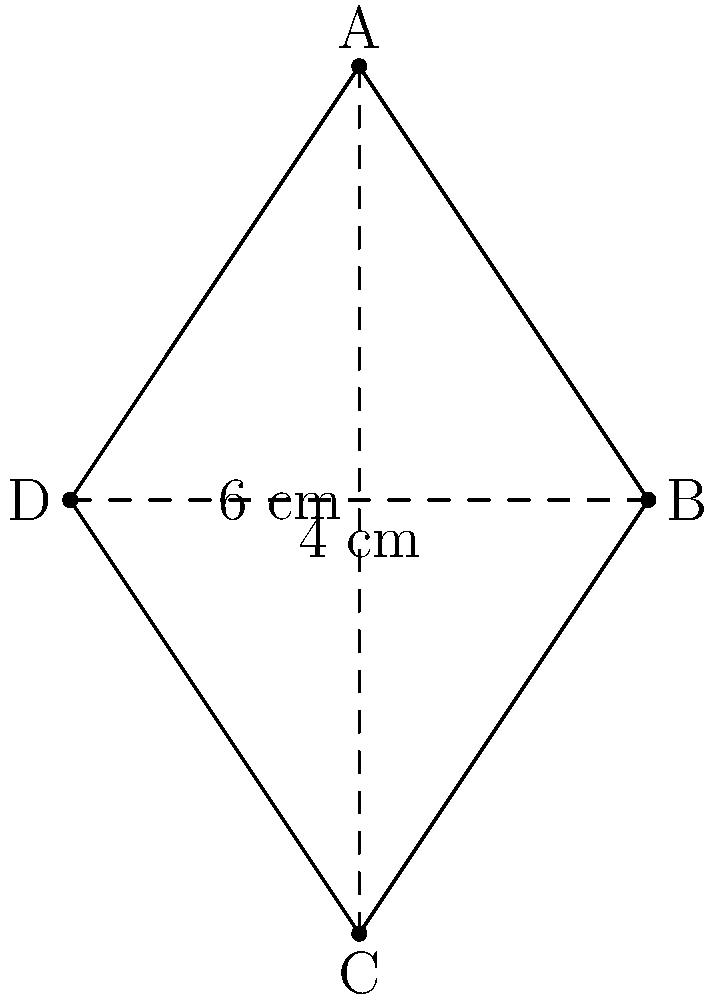Your child has made a beautiful kite-shaped paper craft for a school project. The diagonals of the kite measure 6 cm and 4 cm. What is the area of this paper craft? Consider if this level of precision is appropriate for your child's age and development. Let's approach this step-by-step:

1) The formula for the area of a kite is:
   $$ \text{Area} = \frac{1}{2} \times d_1 \times d_2 $$
   where $d_1$ and $d_2$ are the lengths of the diagonals.

2) We're given that one diagonal is 6 cm and the other is 4 cm.

3) Substituting these values into our formula:
   $$ \text{Area} = \frac{1}{2} \times 6 \text{ cm} \times 4 \text{ cm} $$

4) Simplifying:
   $$ \text{Area} = \frac{1}{2} \times 24 \text{ cm}^2 = 12 \text{ cm}^2 $$

5) Therefore, the area of the kite-shaped paper craft is 12 square centimeters.

It's important to consider whether this level of mathematical precision is appropriate for your child's age and developmental stage. While it's good to encourage learning, it's equally important to ensure that the activities are age-appropriate and don't put undue pressure on young children.
Answer: 12 cm² 